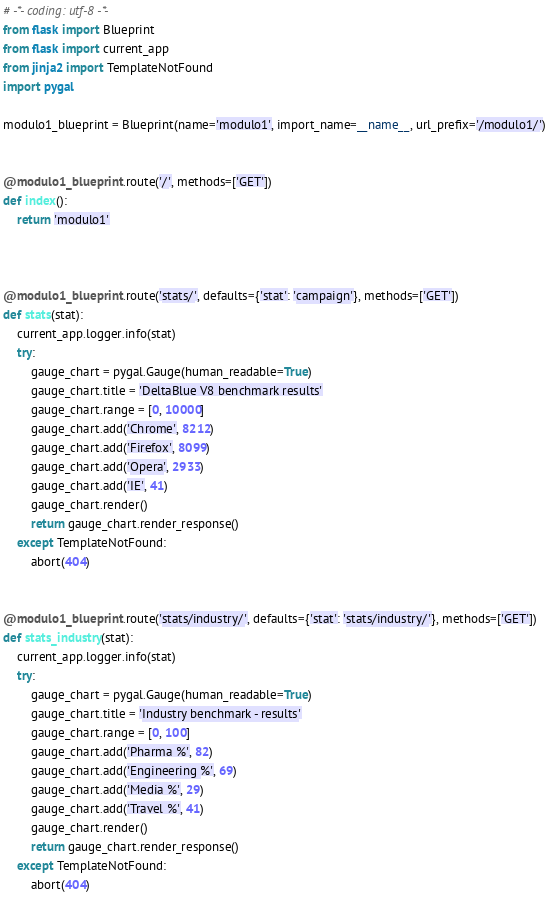<code> <loc_0><loc_0><loc_500><loc_500><_Python_># -*- coding: utf-8 -*-
from flask import Blueprint
from flask import current_app
from jinja2 import TemplateNotFound
import pygal

modulo1_blueprint = Blueprint(name='modulo1', import_name=__name__, url_prefix='/modulo1/')


@modulo1_blueprint.route('/', methods=['GET'])
def index():
    return 'modulo1'



@modulo1_blueprint.route('stats/', defaults={'stat': 'campaign'}, methods=['GET'])
def stats(stat):
    current_app.logger.info(stat)
    try:
        gauge_chart = pygal.Gauge(human_readable=True)
        gauge_chart.title = 'DeltaBlue V8 benchmark results'
        gauge_chart.range = [0, 10000]
        gauge_chart.add('Chrome', 8212)
        gauge_chart.add('Firefox', 8099)
        gauge_chart.add('Opera', 2933)
        gauge_chart.add('IE', 41)
        gauge_chart.render()
        return gauge_chart.render_response()
    except TemplateNotFound:
        abort(404)


@modulo1_blueprint.route('stats/industry/', defaults={'stat': 'stats/industry/'}, methods=['GET'])
def stats_industry(stat):
    current_app.logger.info(stat)
    try:
        gauge_chart = pygal.Gauge(human_readable=True)
        gauge_chart.title = 'Industry benchmark - results'
        gauge_chart.range = [0, 100]
        gauge_chart.add('Pharma %', 82)
        gauge_chart.add('Engineering %', 69)
        gauge_chart.add('Media %', 29)
        gauge_chart.add('Travel %', 41)
        gauge_chart.render()
        return gauge_chart.render_response()
    except TemplateNotFound:
        abort(404)
</code> 